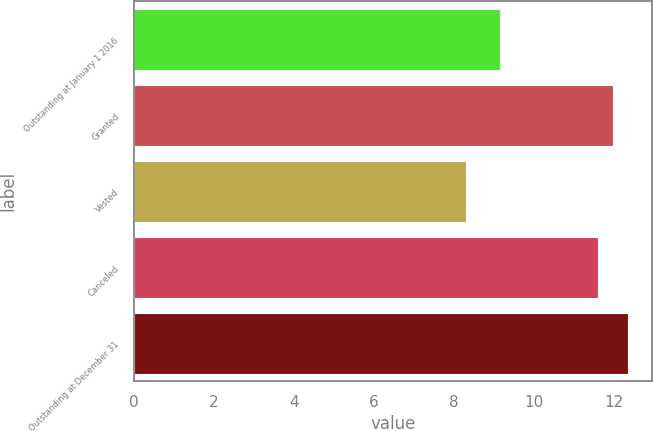<chart> <loc_0><loc_0><loc_500><loc_500><bar_chart><fcel>Outstanding at January 1 2016<fcel>Granted<fcel>Vested<fcel>Canceled<fcel>Outstanding at December 31<nl><fcel>9.14<fcel>11.97<fcel>8.31<fcel>11.6<fcel>12.34<nl></chart> 